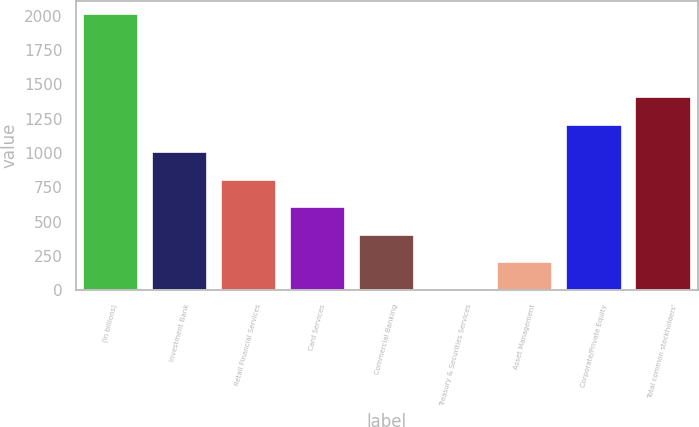Convert chart to OTSL. <chart><loc_0><loc_0><loc_500><loc_500><bar_chart><fcel>(in billions)<fcel>Investment Bank<fcel>Retail Financial Services<fcel>Card Services<fcel>Commercial Banking<fcel>Treasury & Securities Services<fcel>Asset Management<fcel>Corporate/Private Equity<fcel>Total common stockholders'<nl><fcel>2009<fcel>1007<fcel>806.6<fcel>606.2<fcel>405.8<fcel>5<fcel>205.4<fcel>1207.4<fcel>1407.8<nl></chart> 